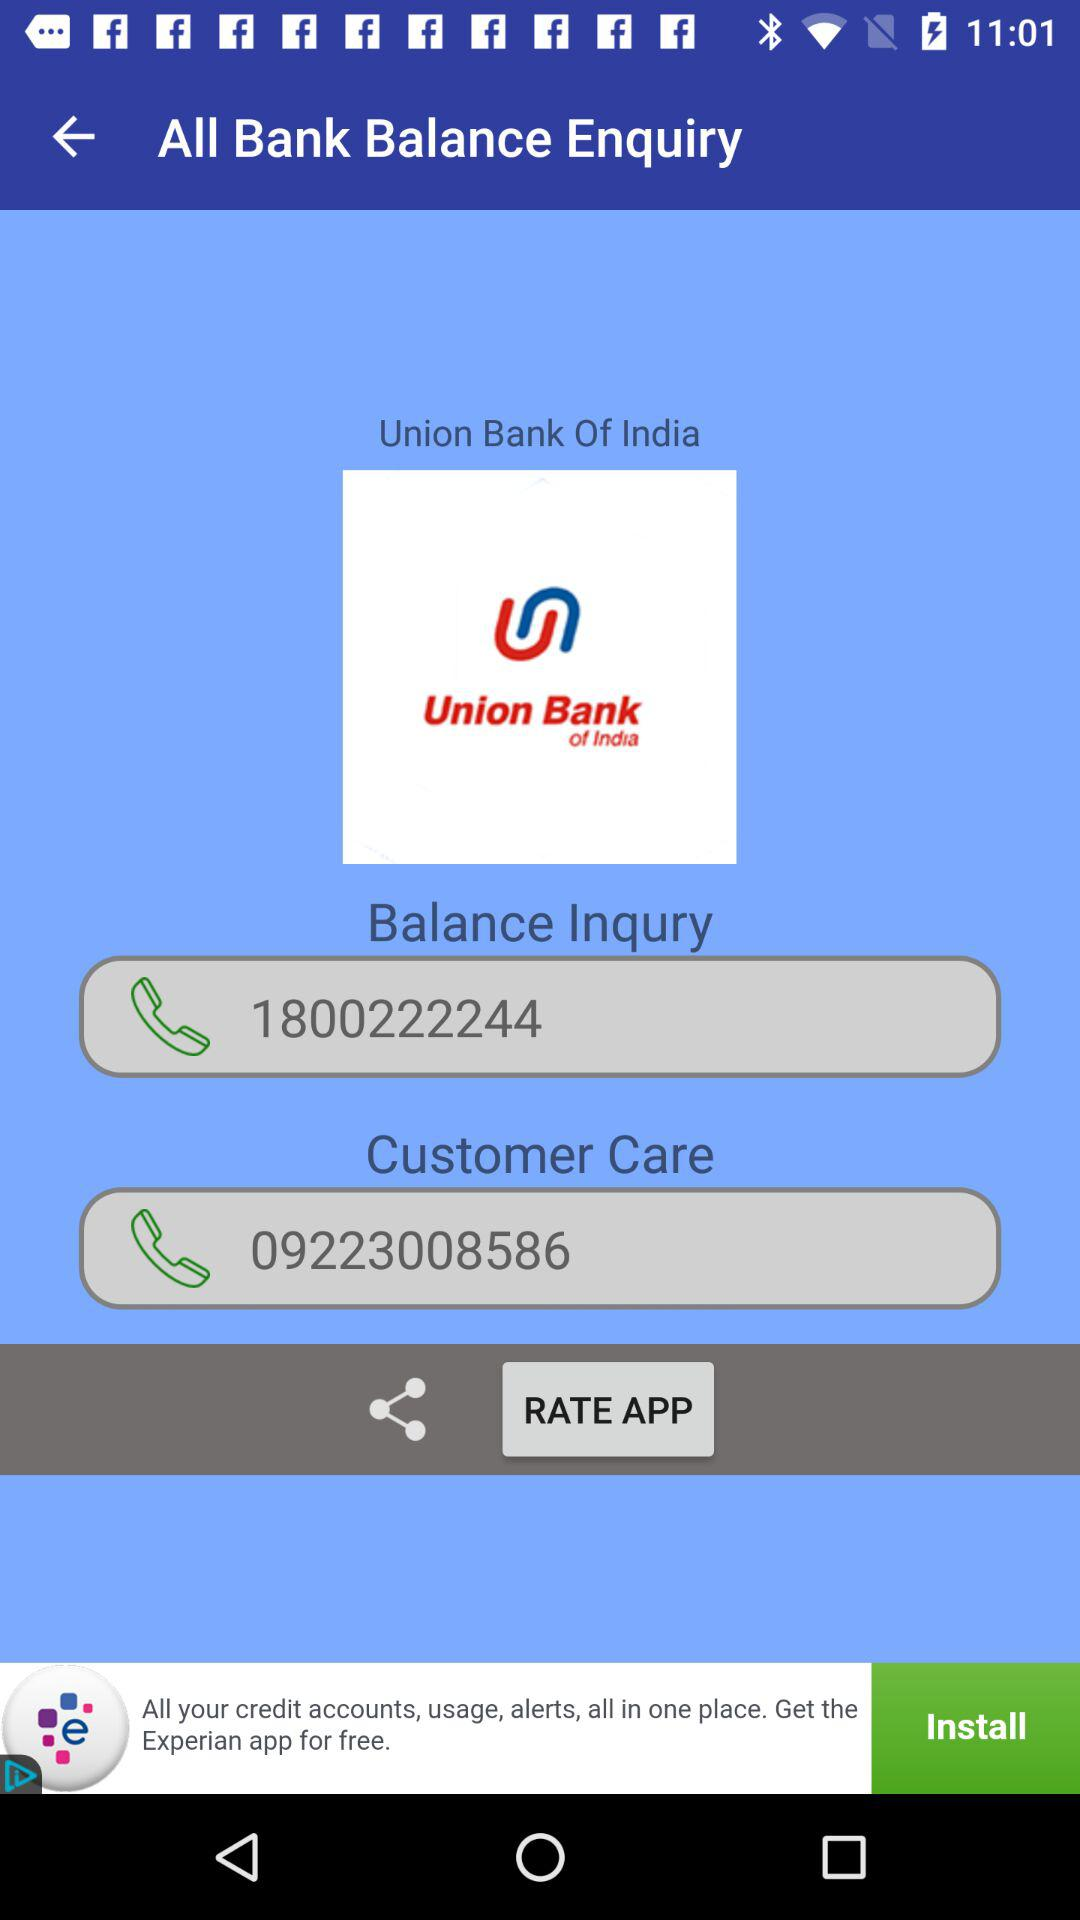What is the contact number for customer care? The contact number for customer care is 09223008586. 